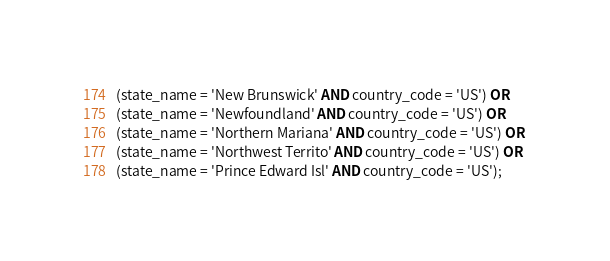Convert code to text. <code><loc_0><loc_0><loc_500><loc_500><_SQL_>(state_name = 'New Brunswick' AND country_code = 'US') OR 
(state_name = 'Newfoundland' AND country_code = 'US') OR 
(state_name = 'Northern Mariana' AND country_code = 'US') OR 
(state_name = 'Northwest Territo' AND country_code = 'US') OR 
(state_name = 'Prince Edward Isl' AND country_code = 'US');
</code> 